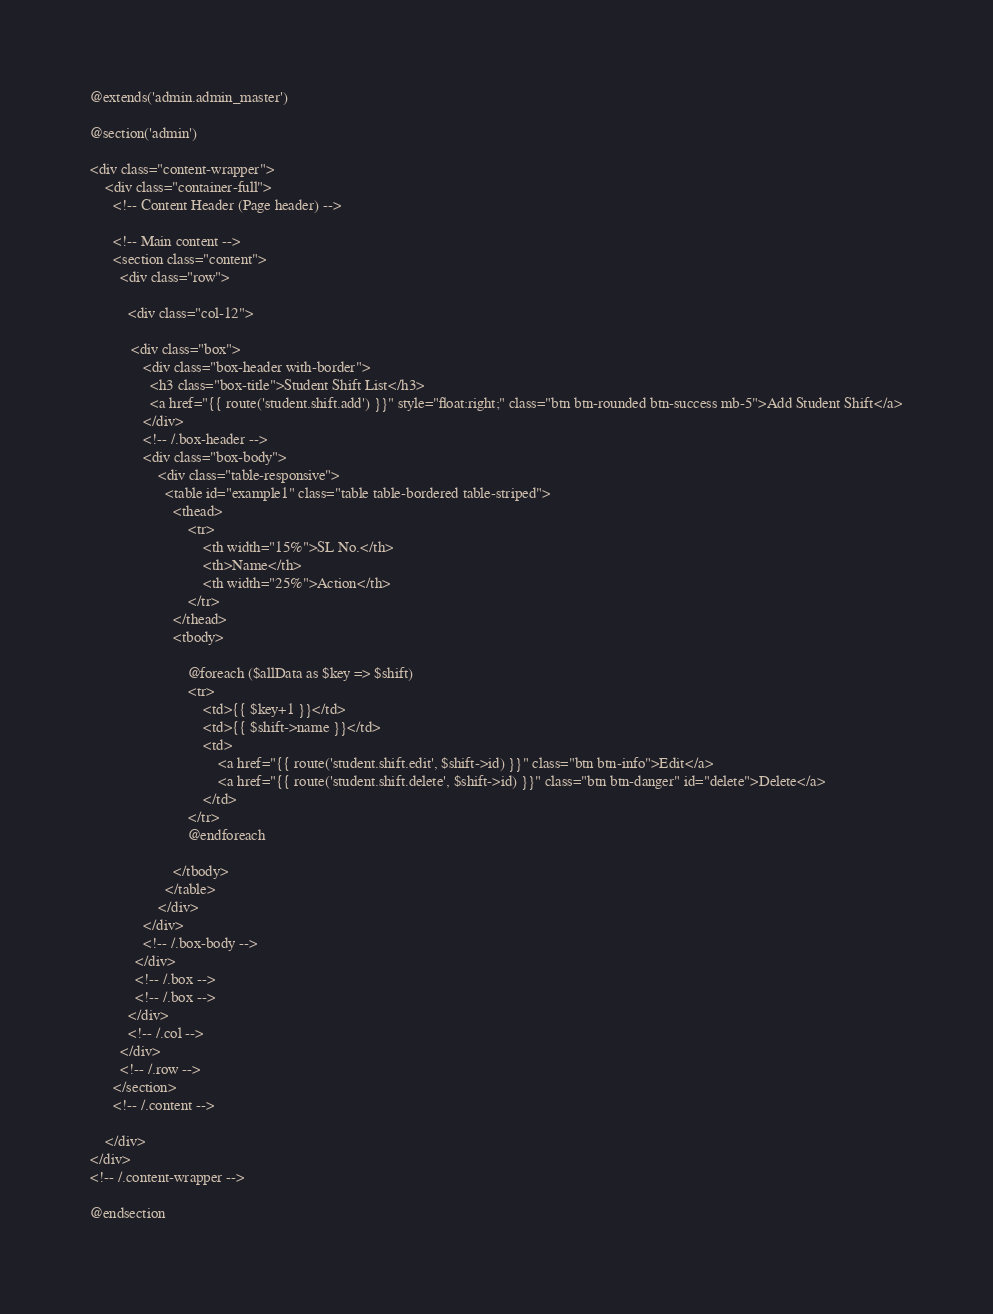Convert code to text. <code><loc_0><loc_0><loc_500><loc_500><_PHP_>@extends('admin.admin_master')

@section('admin')

<div class="content-wrapper">
    <div class="container-full">
      <!-- Content Header (Page header) -->

      <!-- Main content -->
      <section class="content">
        <div class="row">
            
          <div class="col-12">

           <div class="box">
              <div class="box-header with-border">
                <h3 class="box-title">Student Shift List</h3>
                <a href="{{ route('student.shift.add') }}" style="float:right;" class="btn btn-rounded btn-success mb-5">Add Student Shift</a>
              </div>
              <!-- /.box-header -->
              <div class="box-body">
                  <div class="table-responsive">
                    <table id="example1" class="table table-bordered table-striped">
                      <thead>
                          <tr>
                              <th width="15%">SL No.</th>
                              <th>Name</th>
                              <th width="25%">Action</th>
                          </tr>
                      </thead>
                      <tbody>

                          @foreach ($allData as $key => $shift)
                          <tr>
                              <td>{{ $key+1 }}</td>
                              <td>{{ $shift->name }}</td>
                              <td>
                                  <a href="{{ route('student.shift.edit', $shift->id) }}" class="btn btn-info">Edit</a>
                                  <a href="{{ route('student.shift.delete', $shift->id) }}" class="btn btn-danger" id="delete">Delete</a>
                              </td>
                          </tr>
                          @endforeach

                      </tbody>
                    </table>
                  </div>
              </div>
              <!-- /.box-body -->
            </div>
            <!-- /.box -->
            <!-- /.box -->          
          </div>
          <!-- /.col -->
        </div>
        <!-- /.row -->
      </section>
      <!-- /.content -->
    
    </div>
</div>
<!-- /.content-wrapper -->

@endsection</code> 